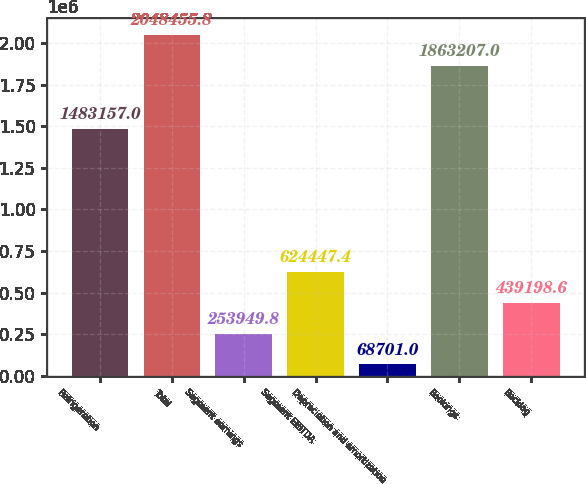Convert chart to OTSL. <chart><loc_0><loc_0><loc_500><loc_500><bar_chart><fcel>Refrigeration<fcel>Total<fcel>Segment earnings<fcel>Segment EBITDA<fcel>Depreciation and amortization<fcel>Bookings<fcel>Backlog<nl><fcel>1.48316e+06<fcel>2.04846e+06<fcel>253950<fcel>624447<fcel>68701<fcel>1.86321e+06<fcel>439199<nl></chart> 